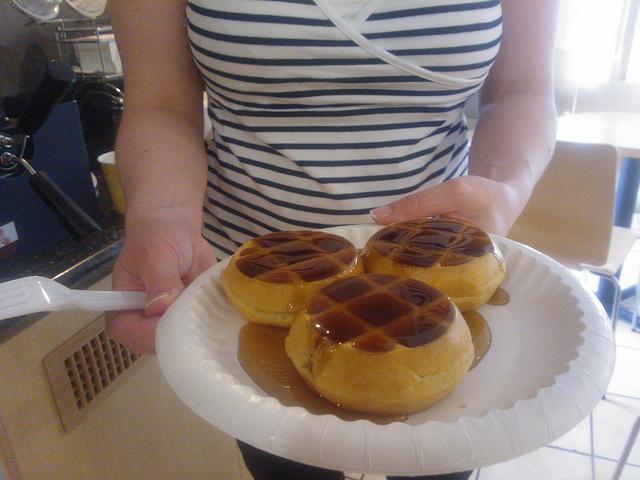What size are the waffles on the plate?
Short answer required. Small. What meal would this generally be served at?
Keep it brief. Breakfast. What color is the plate?
Short answer required. White. 